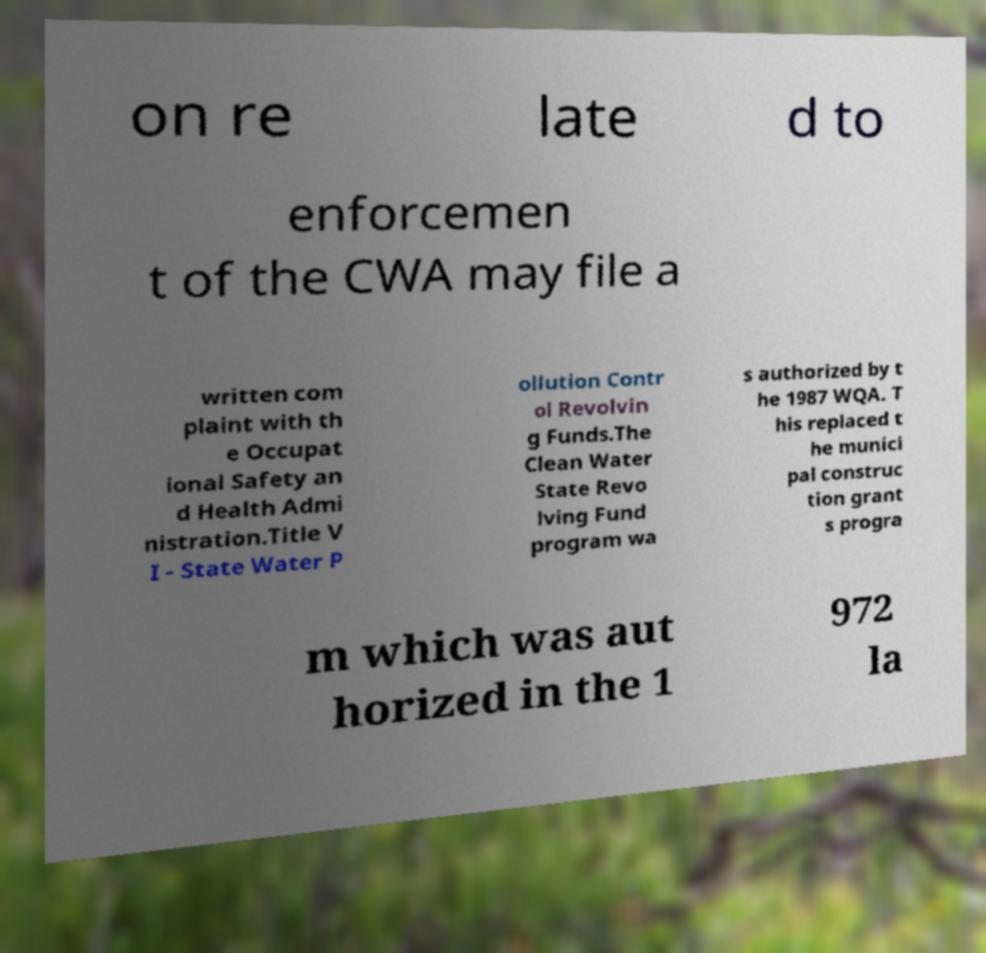Can you read and provide the text displayed in the image?This photo seems to have some interesting text. Can you extract and type it out for me? on re late d to enforcemen t of the CWA may file a written com plaint with th e Occupat ional Safety an d Health Admi nistration.Title V I - State Water P ollution Contr ol Revolvin g Funds.The Clean Water State Revo lving Fund program wa s authorized by t he 1987 WQA. T his replaced t he munici pal construc tion grant s progra m which was aut horized in the 1 972 la 